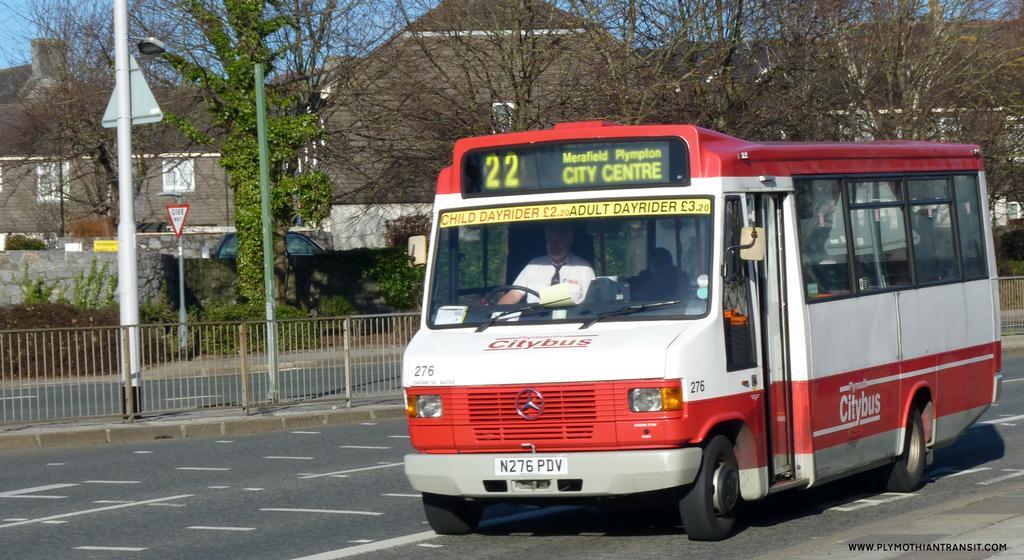How would you summarize this image in a sentence or two? At the bottom of the image, on the road there is a bus. Inside the bus there are few people sitting. And there are names on the bus. Beside the road there is railing. And also there are poles with sign boards and street lights. In the background there are trees and also there are buildings. 